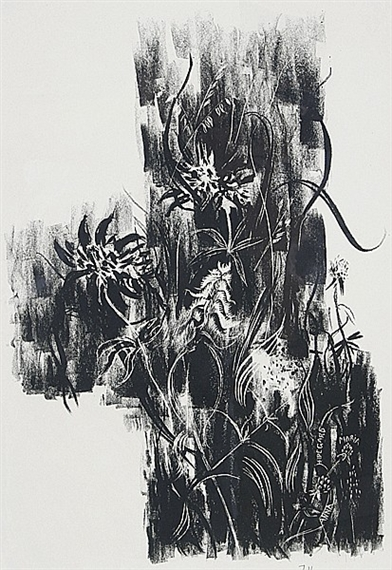What is this photo about'?
 The image you've shared is a captivating piece of abstract art. It's a monochromatic print, dominated by a stark contrast between the black background and the white lines that dance across the canvas. The art style is expressionist, a genre known for its emphasis on emotional and subjective interpretation rather than realistic representation. 

The white lines are fluid and organic, their movement almost reminiscent of a living entity. They weave in and out, creating a sense of depth and texture that draws the viewer in. The lines themselves are a product of the printmaking process, their unique patterns a testament to the artist's skill and creativity. 

Despite its abstract nature, the image evokes a sense of movement and rhythm, as if the lines are in constant flux, changing and evolving with each passing moment. It's a powerful piece that showcases the beauty of abstract expressionism and the endless possibilities of printmaking. 